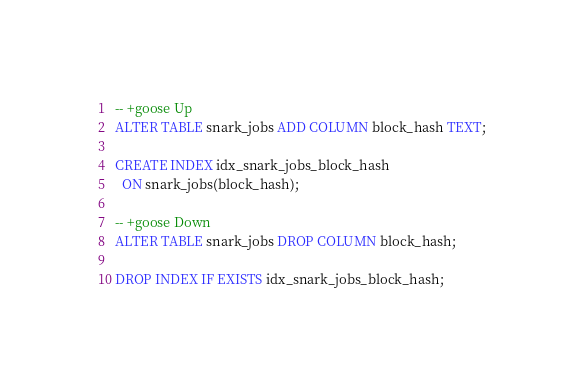Convert code to text. <code><loc_0><loc_0><loc_500><loc_500><_SQL_>-- +goose Up
ALTER TABLE snark_jobs ADD COLUMN block_hash TEXT;

CREATE INDEX idx_snark_jobs_block_hash
  ON snark_jobs(block_hash);

-- +goose Down
ALTER TABLE snark_jobs DROP COLUMN block_hash;

DROP INDEX IF EXISTS idx_snark_jobs_block_hash;</code> 